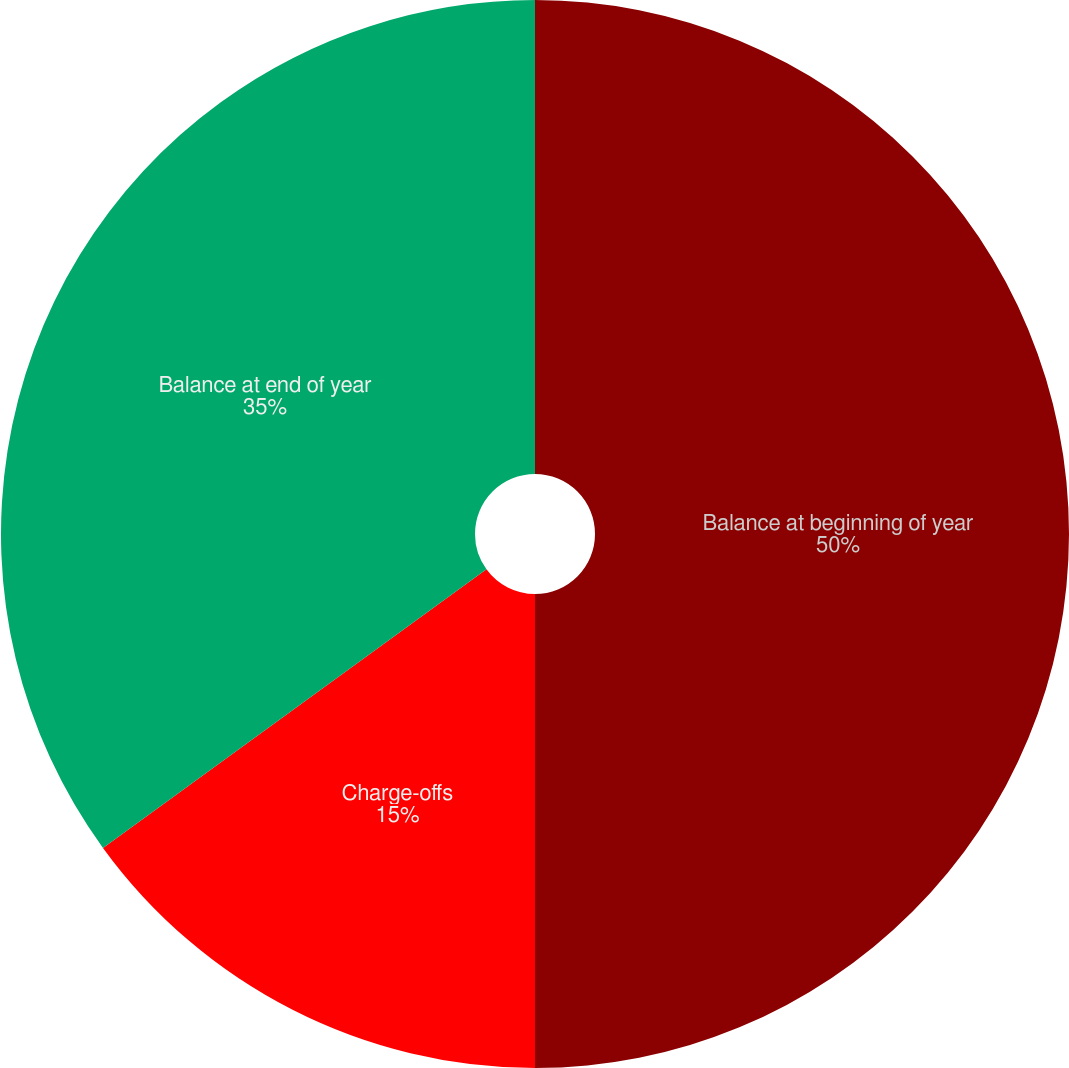Convert chart to OTSL. <chart><loc_0><loc_0><loc_500><loc_500><pie_chart><fcel>Balance at beginning of year<fcel>Charge-offs<fcel>Balance at end of year<nl><fcel>50.0%<fcel>15.0%<fcel>35.0%<nl></chart> 